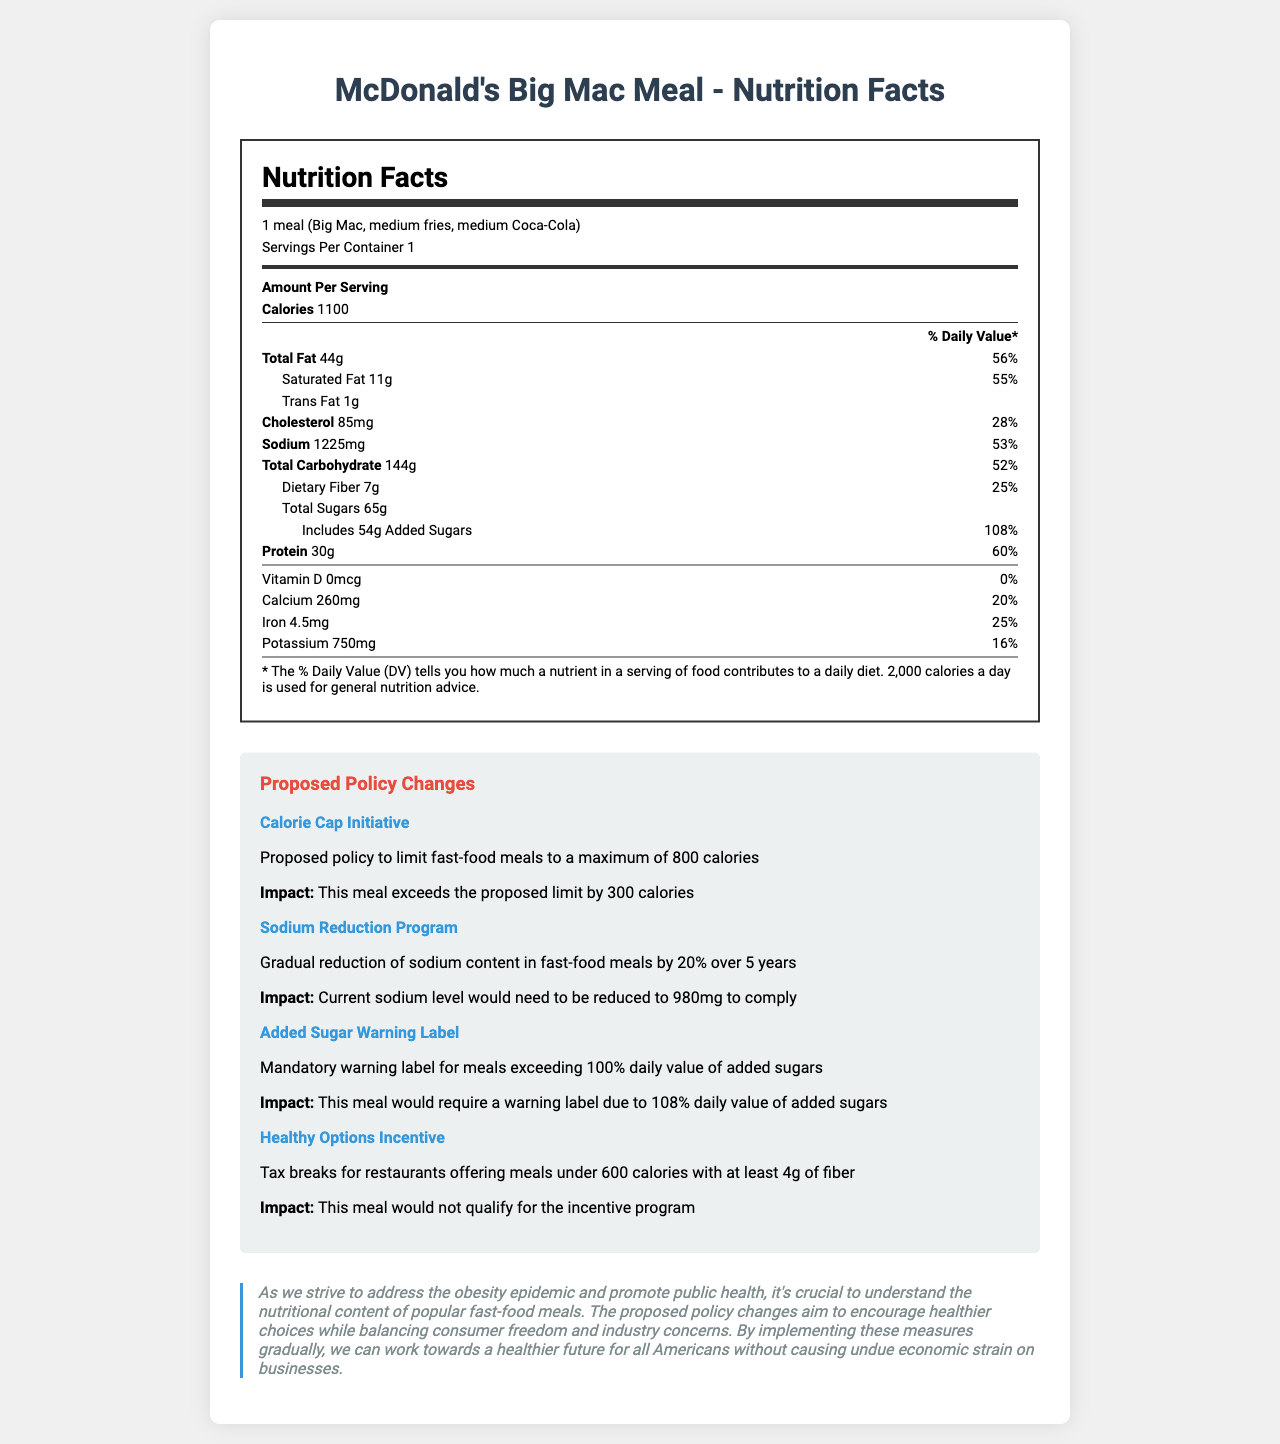What is the serving size for McDonald's Big Mac Meal? The serving size is stated at the top of the Nutrition Facts Label.
Answer: 1 meal (Big Mac, medium fries, medium Coca-Cola) How many calories are in the McDonald's Big Mac Meal? The calorie content is listed under "Amount Per Serving" in the document.
Answer: 1100 What is the daily value percentage of saturated fat in the meal? This information can be found next to the saturated fat amount in the nutrition label.
Answer: 55% How much sodium does the meal contain? The sodium content is provided in the text under the section for sodium.
Answer: 1225mg How much protein is in the meal? The protein amount is listed under the "Amount Per Serving" section.
Answer: 30g What is the proposed calorie limit under the Calorie Cap Initiative? A. 600 calories B. 800 calories C. 1000 calories The calorie limit is specified in the policy change details under "Calorie Cap Initiative."
Answer: B In the Sodium Reduction Program, by how much would the sodium content need to be reduced to comply with the policy? A. 850mg B. 980mg C. 1050mg The required new sodium level is 980mg, as mentioned in the impact section of the Sodium Reduction Program.
Answer: B Will the meal qualify for a tax break under the Healthy Options Incentive program? The policy change description states that this meal would not qualify because it contains more than 600 calories and does not meet the fiber requirement.
Answer: No Should the meal include an added sugar warning label according to the proposed policy changes? The meal would require a warning label as it exceeds 100% of the daily value for added sugars, indicated by the policy.
Answer: Yes Does the meal contain any Vitamin D? The nutrition label shows 0mcg of Vitamin D, which means it contains none.
Answer: No Summarize the main idea of the document. The detailed explanation includes nutritional content details, specifics of the proposed policies, their potential impacts, and a political stance on the importance of these changes to improve public health.
Answer: The document provides detailed nutritional information for McDonald’s Big Mac Meal and highlights several proposed policy changes aimed at promoting healthier fast-food options by targeting calorie, sodium, and added sugar content. The document includes a statement from a politician emphasizing the importance of these changes for public health. What are the reasons behind implementing these policy changes? The document does not provide specific reasons or data about why these policy changes are necessary beyond the general statement about promoting public health.
Answer: Not enough information 